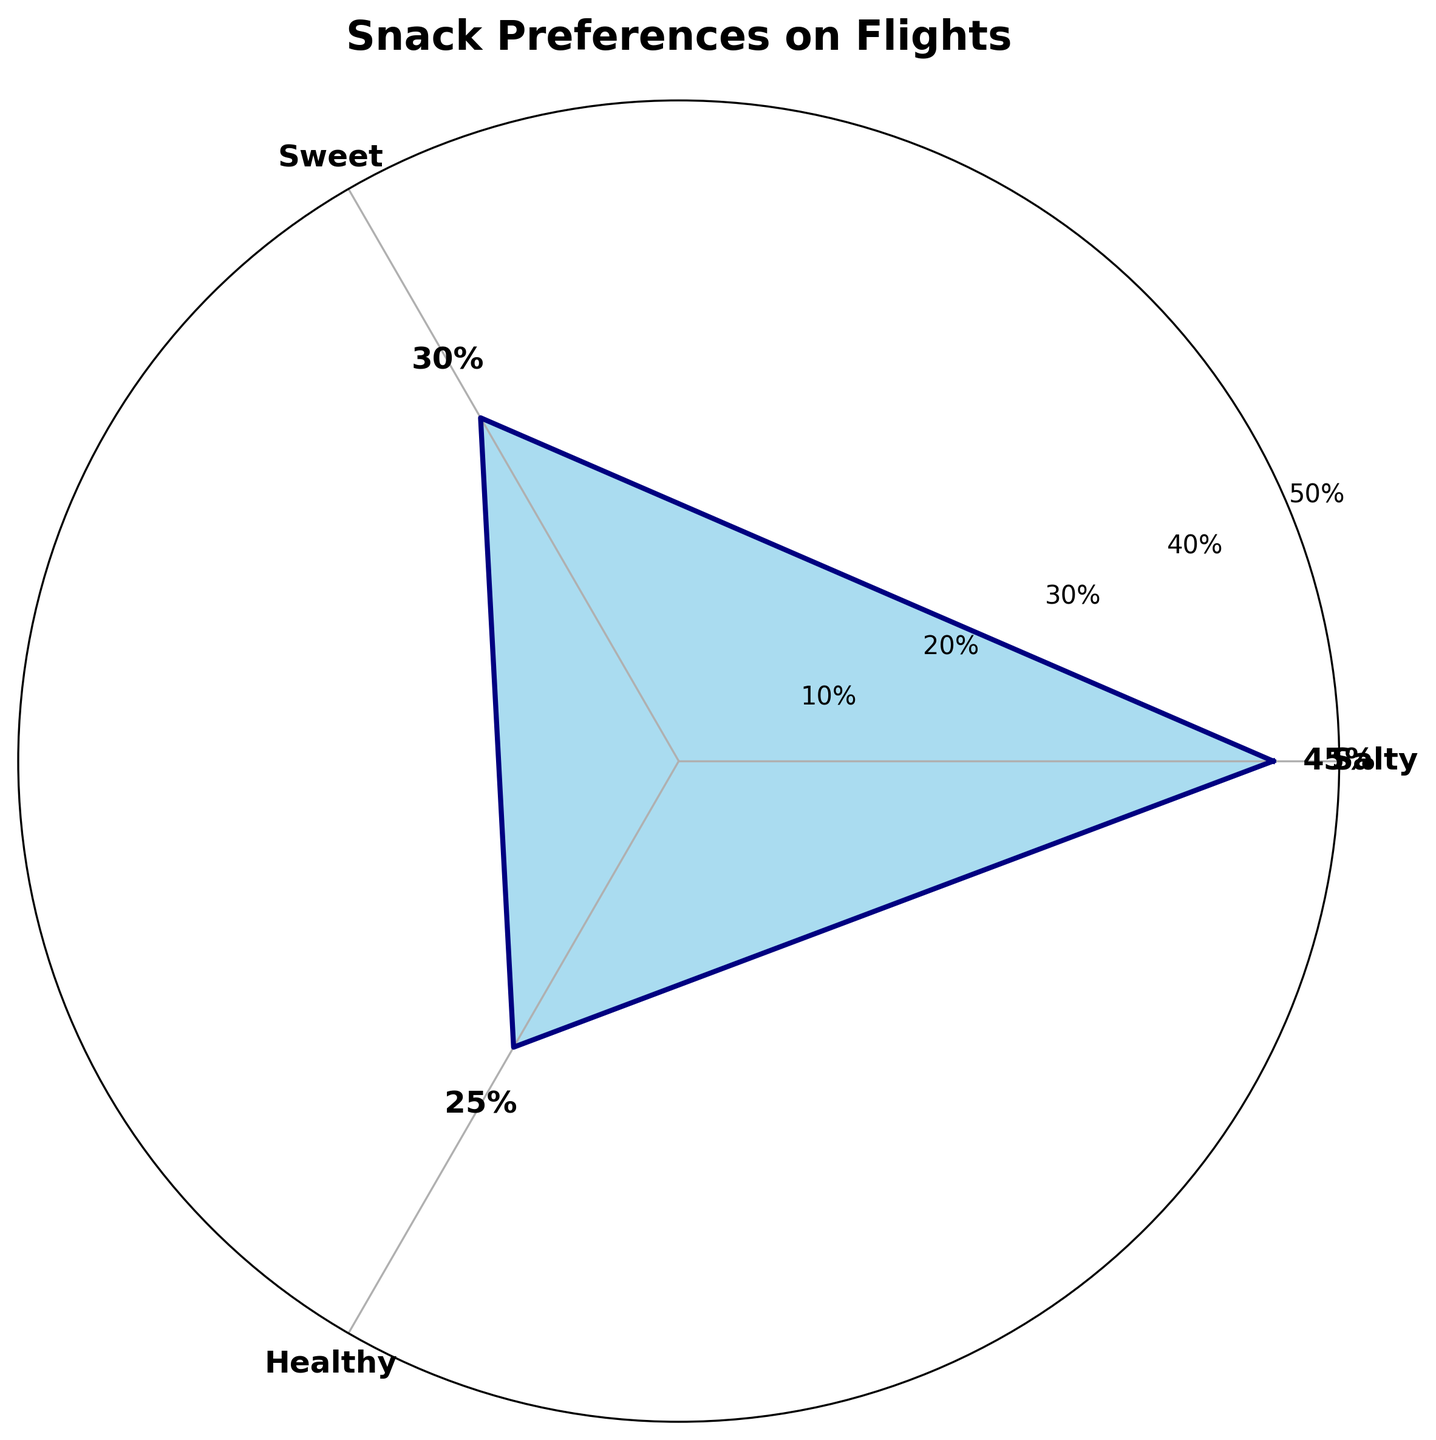What is the title of the figure? The title is usually placed at the top of the chart. In this case, it clearly describes the subject of the plot.
Answer: Snack Preferences on Flights How many snack types are shown in the chart? By counting the labels on the chart, you can see that there are three different snack types represented.
Answer: Three Which snack preference has the highest percentage? Look at the values and annotations on the chart to identify the group with the largest value.
Answer: Salty What is the percentage difference between salty and sweet snacks? Subtract the percentage of sweet snacks from the percentage of salty snacks: 45% - 30% = 15%.
Answer: 15% How do healthy snacks compare to sweet snacks in terms of preference? Compare the percentage values of healthy and sweet snacks directly: 25% is less than 30%.
Answer: Healthy snacks have a lower preference than sweet snacks Which snacks have the smallest share of preferences? Look at the value annotations and the radial extent of each section; the smallest value will indicate the least preferred snack.
Answer: Healthy What is the average percentage preference for the three snack types? Add the percentage values of all three snack types and divide by 3: (45% + 30% + 25%) / 3 = 33.33%.
Answer: 33.33% Are there any snack types with equal preference percentages? Examine each percentage value on the chart and see if any of them match.
Answer: No By how much do sweet and healthy snack preferences together exceed the preference for salty snacks? Add the percentages of sweet and healthy snacks and subtract the percentage of salty snacks: (30% + 25%) - 45% = 10%.
Answer: 10% In which range do the radial ticks lie? Look at the circles intersecting the radial lines; each is labeled with increasing percentages at specific intervals.
Answer: 10% to 50% 